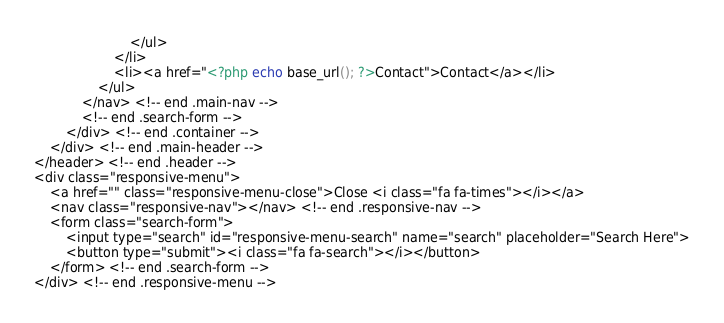Convert code to text. <code><loc_0><loc_0><loc_500><loc_500><_PHP_>						</ul>
					</li>
					<li><a href="<?php echo base_url(); ?>Contact">Contact</a></li>
				</ul>
			</nav> <!-- end .main-nav -->
			<!-- end .search-form -->
		</div> <!-- end .container -->
	</div> <!-- end .main-header -->
</header> <!-- end .header -->
<div class="responsive-menu">
	<a href="" class="responsive-menu-close">Close <i class="fa fa-times"></i></a>
	<nav class="responsive-nav"></nav> <!-- end .responsive-nav -->
	<form class="search-form">
		<input type="search" id="responsive-menu-search" name="search" placeholder="Search Here">
		<button type="submit"><i class="fa fa-search"></i></button>
	</form> <!-- end .search-form -->
</div> <!-- end .responsive-menu -->
</code> 